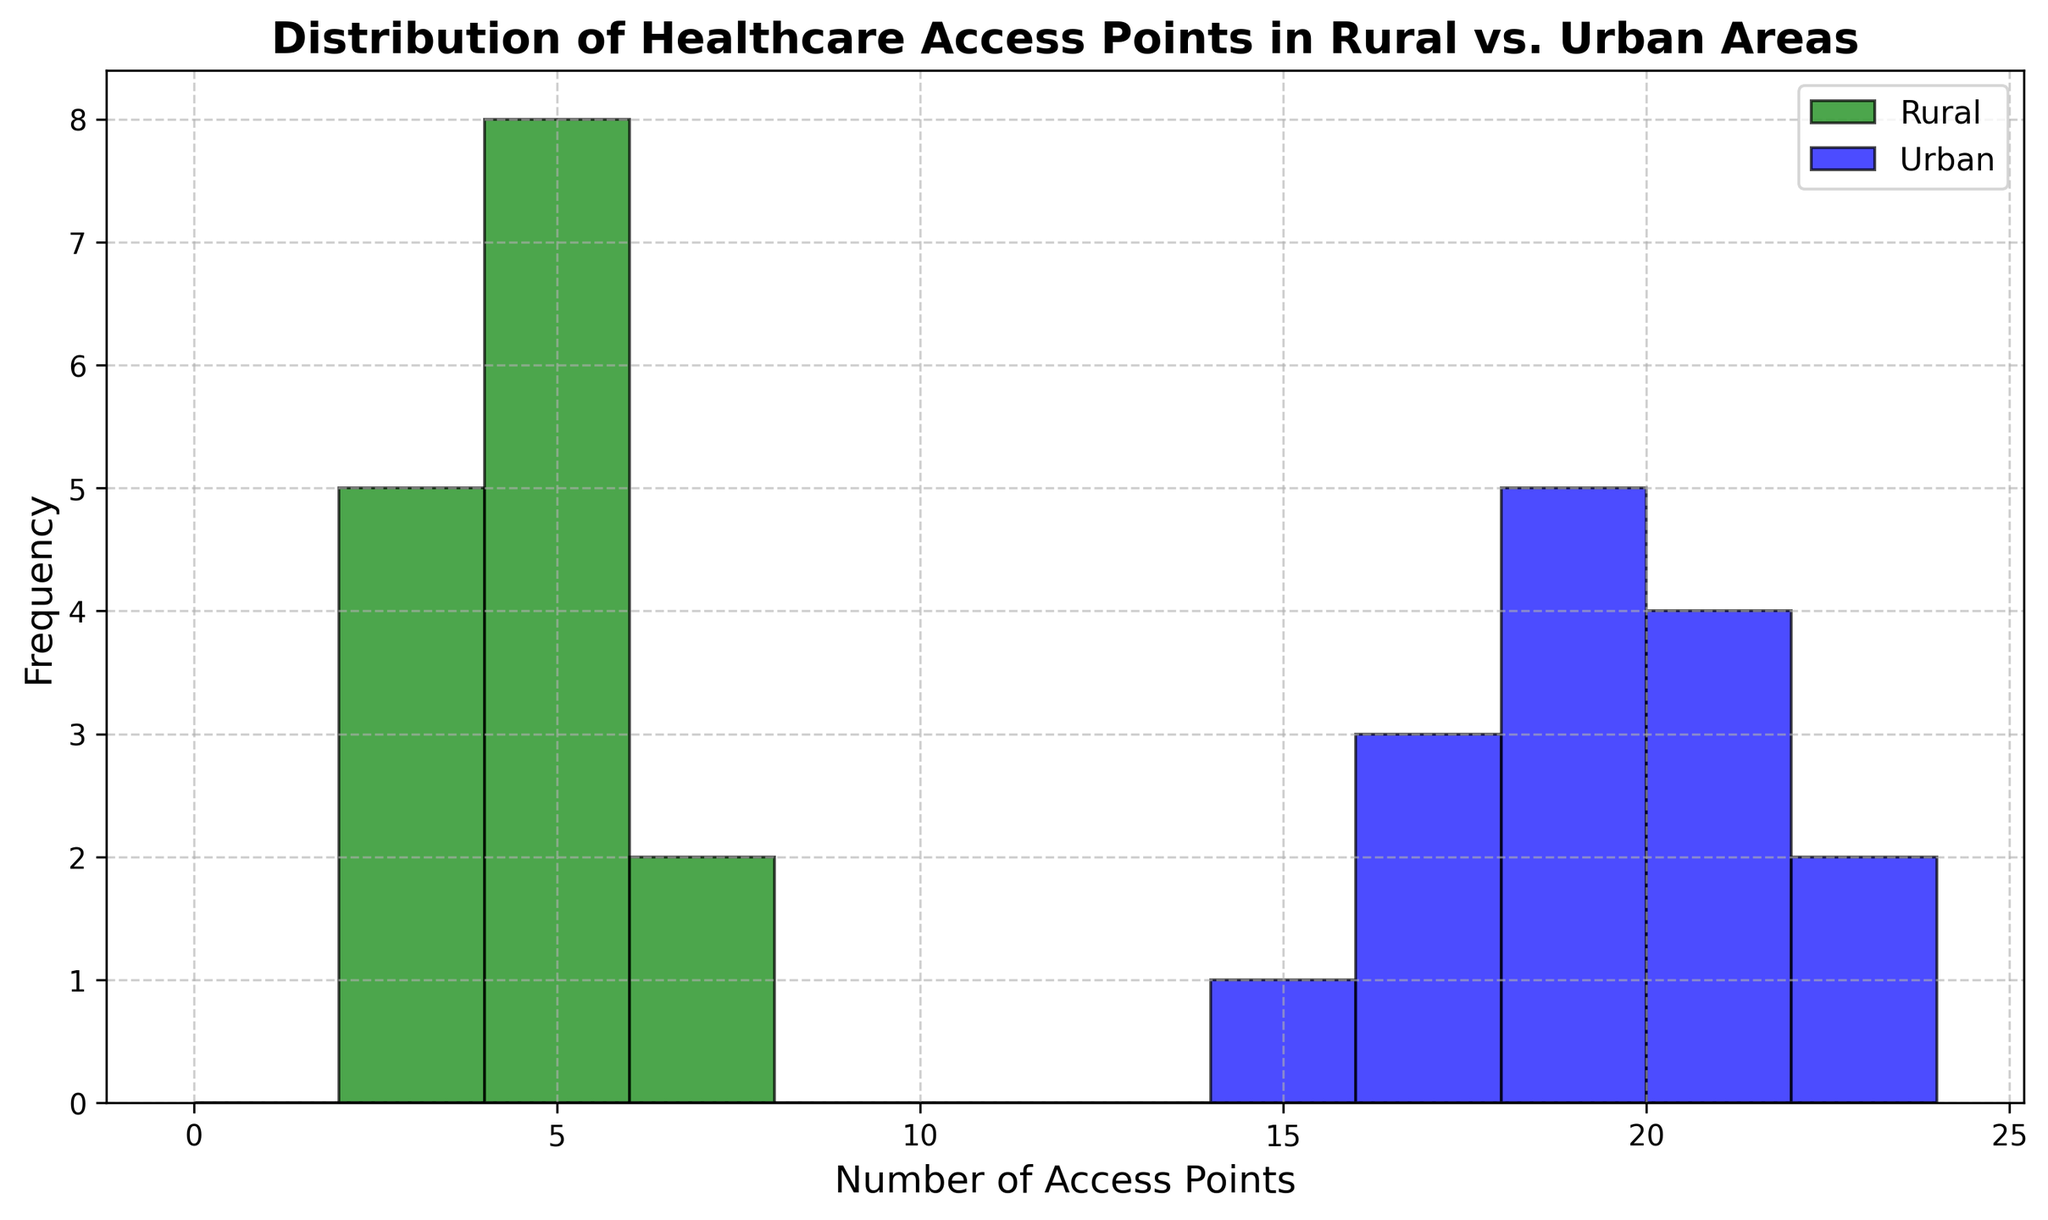Which community has a higher frequency of healthcare access points? Looking at the histogram, we can observe the height of the bars for each community. Urban areas have bars reaching higher frequencies compared to rural areas.
Answer: Urban What is the most common number of access points in rural areas? From the figure, the tallest bar for rural areas is at the number 4 access points, indicating it's the most frequent.
Answer: 4 Which community has a wider range of healthcare access points? Urban areas contain access points ranging from 15 to 22, whereas rural areas range from 2 to 6. The range for urban areas (22 - 15 = 7) is wider than for rural areas (6 - 2 = 4).
Answer: Urban How many access points appear most frequently in urban areas? Checking the tallest bar for the urban areas, it peaks at 18 access points.
Answer: 18 Compare the frequency of rural locations with 4 access points to urban locations with 18 access points. The tallest bar in rural areas corresponds to 4 access points, and a similar height is seen at 18 access points in urban areas. This indicates both frequencies are high but equal.
Answer: Equal By how much does the maximum number of access points in urban areas exceed those in rural areas? The maximum number of access points in urban areas is 22, while it is 6 in rural areas. The difference is 22 - 6 = 16.
Answer: 16 What is the total range of access points (combining both rural and urban areas)? The access points in urban areas range from 15 to 22, while rural areas range from 2 to 6. Combining both ranges, we get from 2 to 22. Therefore, the total range is 22 - 2 = 20.
Answer: 20 Describe the overlap in the number of access points between rural and urban areas. The number of access points in rural areas ranges from 2 to 6 while in urban areas from 15 to 22. There is no overlap because the access point ranges are disjoint.
Answer: No overlap Comparing the frequency distribution, do urban areas tend to have more access points than rural areas? Urban areas have more access points per location, as indicated by the higher number of access points (15 to 22) compared to rural areas (2 to 6).
Answer: Yes 